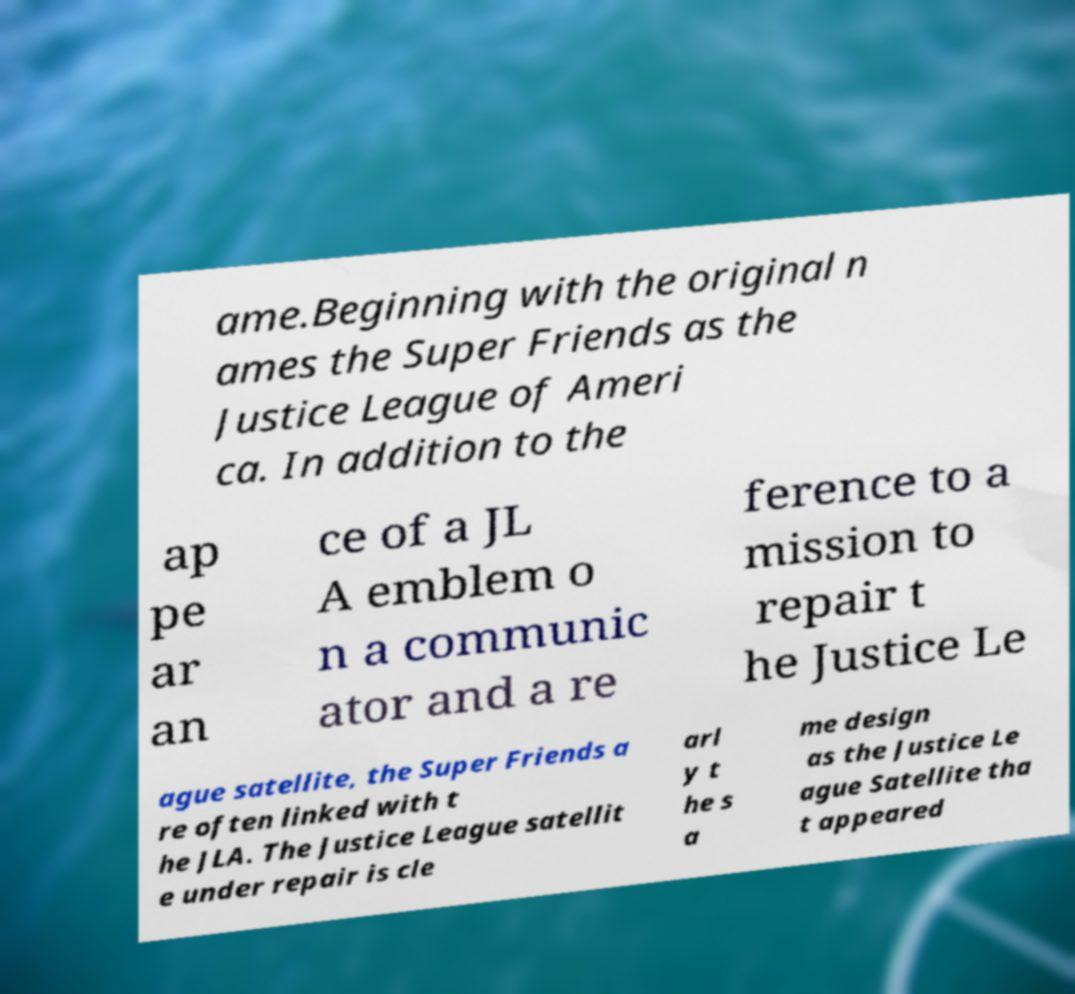Please identify and transcribe the text found in this image. ame.Beginning with the original n ames the Super Friends as the Justice League of Ameri ca. In addition to the ap pe ar an ce of a JL A emblem o n a communic ator and a re ference to a mission to repair t he Justice Le ague satellite, the Super Friends a re often linked with t he JLA. The Justice League satellit e under repair is cle arl y t he s a me design as the Justice Le ague Satellite tha t appeared 